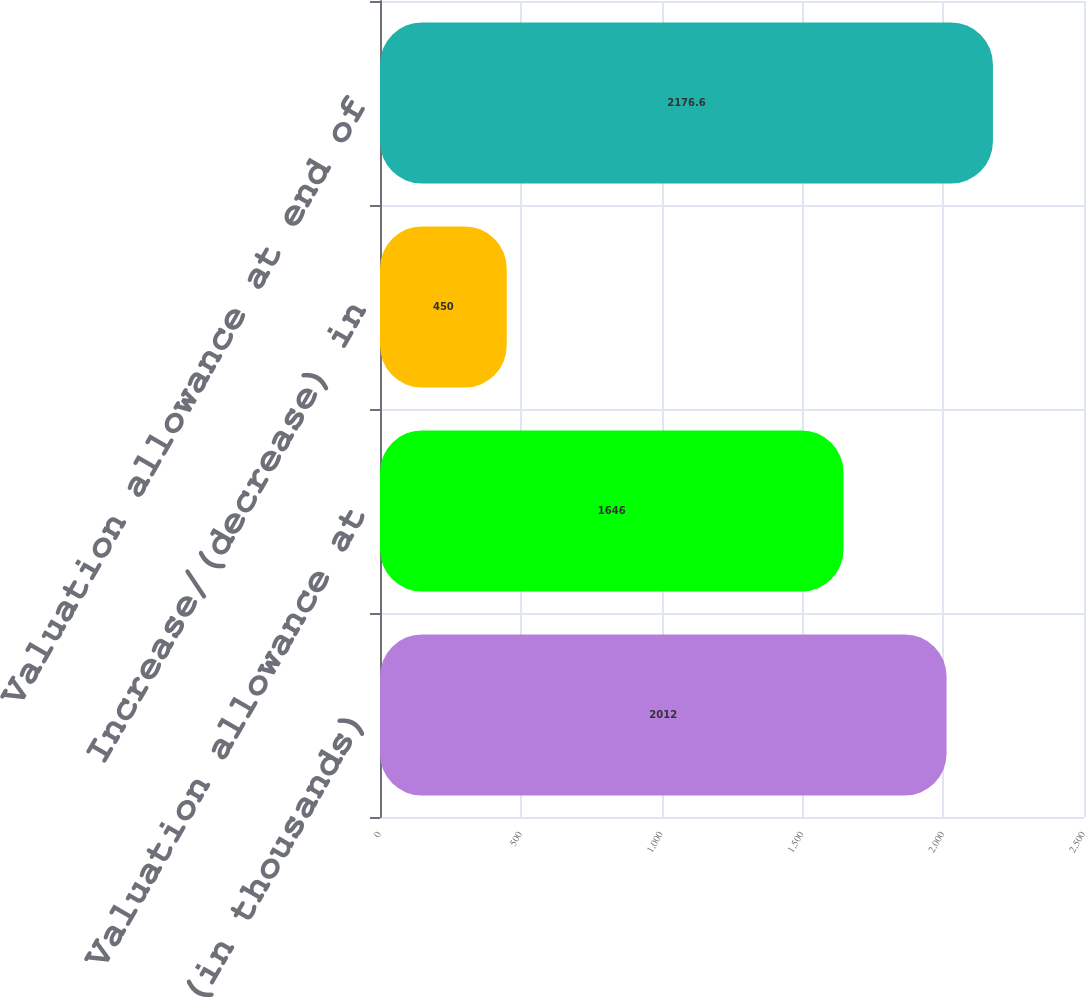<chart> <loc_0><loc_0><loc_500><loc_500><bar_chart><fcel>(in thousands)<fcel>Valuation allowance at<fcel>Increase/(decrease) in<fcel>Valuation allowance at end of<nl><fcel>2012<fcel>1646<fcel>450<fcel>2176.6<nl></chart> 